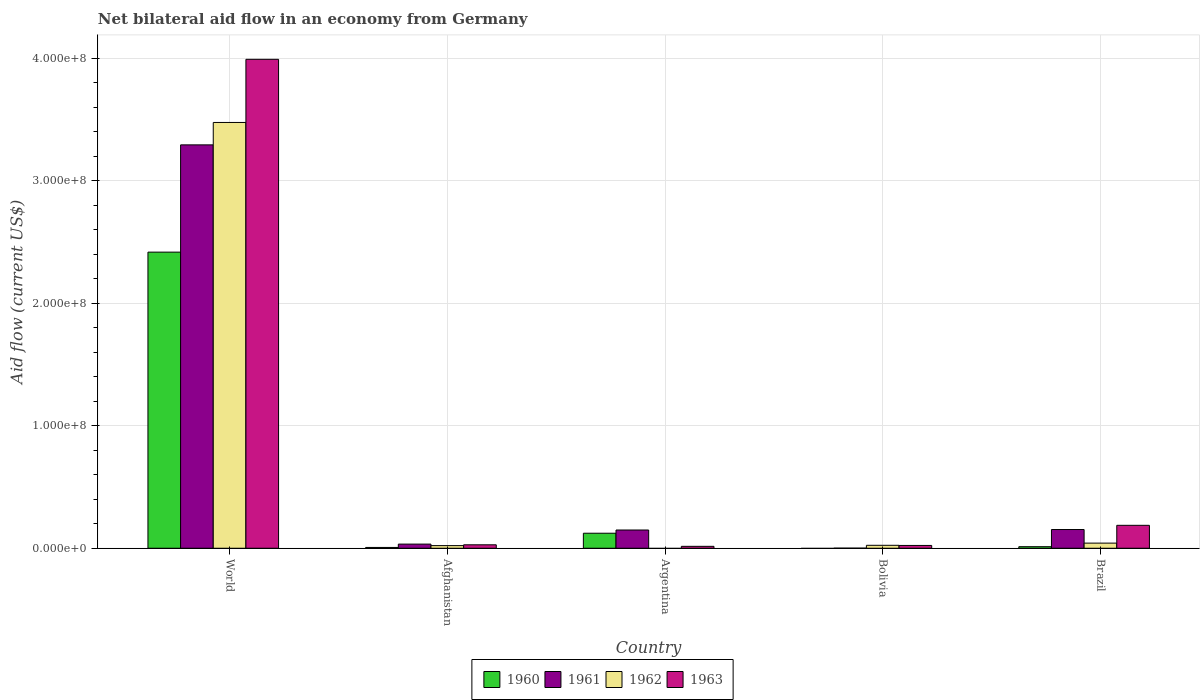How many groups of bars are there?
Your response must be concise. 5. Are the number of bars on each tick of the X-axis equal?
Give a very brief answer. No. How many bars are there on the 5th tick from the left?
Ensure brevity in your answer.  4. What is the net bilateral aid flow in 1963 in Bolivia?
Offer a very short reply. 2.28e+06. Across all countries, what is the maximum net bilateral aid flow in 1961?
Offer a terse response. 3.29e+08. What is the total net bilateral aid flow in 1963 in the graph?
Your answer should be compact. 4.24e+08. What is the difference between the net bilateral aid flow in 1963 in Argentina and that in Bolivia?
Your answer should be very brief. -7.20e+05. What is the difference between the net bilateral aid flow in 1960 in Brazil and the net bilateral aid flow in 1962 in Argentina?
Provide a succinct answer. 1.26e+06. What is the average net bilateral aid flow in 1962 per country?
Make the answer very short. 7.12e+07. What is the difference between the net bilateral aid flow of/in 1962 and net bilateral aid flow of/in 1960 in World?
Offer a very short reply. 1.06e+08. In how many countries, is the net bilateral aid flow in 1963 greater than 120000000 US$?
Your response must be concise. 1. What is the ratio of the net bilateral aid flow in 1962 in Afghanistan to that in World?
Offer a very short reply. 0.01. What is the difference between the highest and the second highest net bilateral aid flow in 1961?
Keep it short and to the point. 3.14e+08. What is the difference between the highest and the lowest net bilateral aid flow in 1963?
Your answer should be compact. 3.97e+08. In how many countries, is the net bilateral aid flow in 1960 greater than the average net bilateral aid flow in 1960 taken over all countries?
Make the answer very short. 1. Is it the case that in every country, the sum of the net bilateral aid flow in 1960 and net bilateral aid flow in 1963 is greater than the sum of net bilateral aid flow in 1962 and net bilateral aid flow in 1961?
Ensure brevity in your answer.  No. What is the difference between two consecutive major ticks on the Y-axis?
Offer a very short reply. 1.00e+08. Are the values on the major ticks of Y-axis written in scientific E-notation?
Provide a succinct answer. Yes. How are the legend labels stacked?
Provide a short and direct response. Horizontal. What is the title of the graph?
Provide a short and direct response. Net bilateral aid flow in an economy from Germany. What is the label or title of the X-axis?
Make the answer very short. Country. What is the Aid flow (current US$) of 1960 in World?
Keep it short and to the point. 2.42e+08. What is the Aid flow (current US$) of 1961 in World?
Your response must be concise. 3.29e+08. What is the Aid flow (current US$) in 1962 in World?
Your answer should be compact. 3.47e+08. What is the Aid flow (current US$) of 1963 in World?
Ensure brevity in your answer.  3.99e+08. What is the Aid flow (current US$) in 1960 in Afghanistan?
Provide a short and direct response. 6.50e+05. What is the Aid flow (current US$) of 1961 in Afghanistan?
Your answer should be compact. 3.38e+06. What is the Aid flow (current US$) of 1962 in Afghanistan?
Ensure brevity in your answer.  2.15e+06. What is the Aid flow (current US$) in 1963 in Afghanistan?
Your answer should be very brief. 2.81e+06. What is the Aid flow (current US$) in 1960 in Argentina?
Offer a terse response. 1.23e+07. What is the Aid flow (current US$) in 1961 in Argentina?
Provide a short and direct response. 1.49e+07. What is the Aid flow (current US$) of 1963 in Argentina?
Offer a terse response. 1.56e+06. What is the Aid flow (current US$) of 1961 in Bolivia?
Offer a terse response. 7.00e+04. What is the Aid flow (current US$) of 1962 in Bolivia?
Give a very brief answer. 2.40e+06. What is the Aid flow (current US$) of 1963 in Bolivia?
Make the answer very short. 2.28e+06. What is the Aid flow (current US$) in 1960 in Brazil?
Provide a short and direct response. 1.26e+06. What is the Aid flow (current US$) in 1961 in Brazil?
Offer a very short reply. 1.53e+07. What is the Aid flow (current US$) in 1962 in Brazil?
Provide a succinct answer. 4.19e+06. What is the Aid flow (current US$) of 1963 in Brazil?
Your answer should be very brief. 1.87e+07. Across all countries, what is the maximum Aid flow (current US$) in 1960?
Provide a succinct answer. 2.42e+08. Across all countries, what is the maximum Aid flow (current US$) in 1961?
Offer a very short reply. 3.29e+08. Across all countries, what is the maximum Aid flow (current US$) of 1962?
Offer a very short reply. 3.47e+08. Across all countries, what is the maximum Aid flow (current US$) in 1963?
Make the answer very short. 3.99e+08. Across all countries, what is the minimum Aid flow (current US$) of 1963?
Provide a succinct answer. 1.56e+06. What is the total Aid flow (current US$) in 1960 in the graph?
Your response must be concise. 2.56e+08. What is the total Aid flow (current US$) of 1961 in the graph?
Your answer should be very brief. 3.63e+08. What is the total Aid flow (current US$) of 1962 in the graph?
Provide a succinct answer. 3.56e+08. What is the total Aid flow (current US$) in 1963 in the graph?
Provide a succinct answer. 4.24e+08. What is the difference between the Aid flow (current US$) in 1960 in World and that in Afghanistan?
Provide a succinct answer. 2.41e+08. What is the difference between the Aid flow (current US$) of 1961 in World and that in Afghanistan?
Make the answer very short. 3.26e+08. What is the difference between the Aid flow (current US$) of 1962 in World and that in Afghanistan?
Your response must be concise. 3.45e+08. What is the difference between the Aid flow (current US$) in 1963 in World and that in Afghanistan?
Your answer should be compact. 3.96e+08. What is the difference between the Aid flow (current US$) of 1960 in World and that in Argentina?
Give a very brief answer. 2.29e+08. What is the difference between the Aid flow (current US$) of 1961 in World and that in Argentina?
Your answer should be very brief. 3.14e+08. What is the difference between the Aid flow (current US$) in 1963 in World and that in Argentina?
Keep it short and to the point. 3.97e+08. What is the difference between the Aid flow (current US$) in 1961 in World and that in Bolivia?
Offer a terse response. 3.29e+08. What is the difference between the Aid flow (current US$) of 1962 in World and that in Bolivia?
Your answer should be very brief. 3.45e+08. What is the difference between the Aid flow (current US$) in 1963 in World and that in Bolivia?
Your answer should be very brief. 3.97e+08. What is the difference between the Aid flow (current US$) of 1960 in World and that in Brazil?
Give a very brief answer. 2.40e+08. What is the difference between the Aid flow (current US$) of 1961 in World and that in Brazil?
Your answer should be very brief. 3.14e+08. What is the difference between the Aid flow (current US$) of 1962 in World and that in Brazil?
Provide a short and direct response. 3.43e+08. What is the difference between the Aid flow (current US$) in 1963 in World and that in Brazil?
Keep it short and to the point. 3.80e+08. What is the difference between the Aid flow (current US$) of 1960 in Afghanistan and that in Argentina?
Keep it short and to the point. -1.16e+07. What is the difference between the Aid flow (current US$) in 1961 in Afghanistan and that in Argentina?
Give a very brief answer. -1.15e+07. What is the difference between the Aid flow (current US$) in 1963 in Afghanistan and that in Argentina?
Ensure brevity in your answer.  1.25e+06. What is the difference between the Aid flow (current US$) of 1961 in Afghanistan and that in Bolivia?
Give a very brief answer. 3.31e+06. What is the difference between the Aid flow (current US$) of 1962 in Afghanistan and that in Bolivia?
Provide a short and direct response. -2.50e+05. What is the difference between the Aid flow (current US$) in 1963 in Afghanistan and that in Bolivia?
Make the answer very short. 5.30e+05. What is the difference between the Aid flow (current US$) of 1960 in Afghanistan and that in Brazil?
Offer a very short reply. -6.10e+05. What is the difference between the Aid flow (current US$) in 1961 in Afghanistan and that in Brazil?
Make the answer very short. -1.19e+07. What is the difference between the Aid flow (current US$) in 1962 in Afghanistan and that in Brazil?
Your response must be concise. -2.04e+06. What is the difference between the Aid flow (current US$) of 1963 in Afghanistan and that in Brazil?
Give a very brief answer. -1.59e+07. What is the difference between the Aid flow (current US$) of 1961 in Argentina and that in Bolivia?
Your answer should be very brief. 1.48e+07. What is the difference between the Aid flow (current US$) in 1963 in Argentina and that in Bolivia?
Your answer should be very brief. -7.20e+05. What is the difference between the Aid flow (current US$) of 1960 in Argentina and that in Brazil?
Give a very brief answer. 1.10e+07. What is the difference between the Aid flow (current US$) of 1961 in Argentina and that in Brazil?
Give a very brief answer. -3.90e+05. What is the difference between the Aid flow (current US$) of 1963 in Argentina and that in Brazil?
Ensure brevity in your answer.  -1.71e+07. What is the difference between the Aid flow (current US$) of 1961 in Bolivia and that in Brazil?
Keep it short and to the point. -1.52e+07. What is the difference between the Aid flow (current US$) of 1962 in Bolivia and that in Brazil?
Keep it short and to the point. -1.79e+06. What is the difference between the Aid flow (current US$) in 1963 in Bolivia and that in Brazil?
Your response must be concise. -1.64e+07. What is the difference between the Aid flow (current US$) in 1960 in World and the Aid flow (current US$) in 1961 in Afghanistan?
Make the answer very short. 2.38e+08. What is the difference between the Aid flow (current US$) of 1960 in World and the Aid flow (current US$) of 1962 in Afghanistan?
Make the answer very short. 2.39e+08. What is the difference between the Aid flow (current US$) of 1960 in World and the Aid flow (current US$) of 1963 in Afghanistan?
Your answer should be compact. 2.39e+08. What is the difference between the Aid flow (current US$) in 1961 in World and the Aid flow (current US$) in 1962 in Afghanistan?
Provide a succinct answer. 3.27e+08. What is the difference between the Aid flow (current US$) in 1961 in World and the Aid flow (current US$) in 1963 in Afghanistan?
Keep it short and to the point. 3.26e+08. What is the difference between the Aid flow (current US$) of 1962 in World and the Aid flow (current US$) of 1963 in Afghanistan?
Provide a succinct answer. 3.45e+08. What is the difference between the Aid flow (current US$) of 1960 in World and the Aid flow (current US$) of 1961 in Argentina?
Your response must be concise. 2.27e+08. What is the difference between the Aid flow (current US$) of 1960 in World and the Aid flow (current US$) of 1963 in Argentina?
Ensure brevity in your answer.  2.40e+08. What is the difference between the Aid flow (current US$) in 1961 in World and the Aid flow (current US$) in 1963 in Argentina?
Provide a succinct answer. 3.28e+08. What is the difference between the Aid flow (current US$) of 1962 in World and the Aid flow (current US$) of 1963 in Argentina?
Keep it short and to the point. 3.46e+08. What is the difference between the Aid flow (current US$) of 1960 in World and the Aid flow (current US$) of 1961 in Bolivia?
Your answer should be very brief. 2.42e+08. What is the difference between the Aid flow (current US$) of 1960 in World and the Aid flow (current US$) of 1962 in Bolivia?
Provide a succinct answer. 2.39e+08. What is the difference between the Aid flow (current US$) of 1960 in World and the Aid flow (current US$) of 1963 in Bolivia?
Your answer should be compact. 2.39e+08. What is the difference between the Aid flow (current US$) in 1961 in World and the Aid flow (current US$) in 1962 in Bolivia?
Make the answer very short. 3.27e+08. What is the difference between the Aid flow (current US$) of 1961 in World and the Aid flow (current US$) of 1963 in Bolivia?
Ensure brevity in your answer.  3.27e+08. What is the difference between the Aid flow (current US$) in 1962 in World and the Aid flow (current US$) in 1963 in Bolivia?
Give a very brief answer. 3.45e+08. What is the difference between the Aid flow (current US$) of 1960 in World and the Aid flow (current US$) of 1961 in Brazil?
Offer a terse response. 2.26e+08. What is the difference between the Aid flow (current US$) of 1960 in World and the Aid flow (current US$) of 1962 in Brazil?
Keep it short and to the point. 2.37e+08. What is the difference between the Aid flow (current US$) in 1960 in World and the Aid flow (current US$) in 1963 in Brazil?
Offer a terse response. 2.23e+08. What is the difference between the Aid flow (current US$) in 1961 in World and the Aid flow (current US$) in 1962 in Brazil?
Make the answer very short. 3.25e+08. What is the difference between the Aid flow (current US$) of 1961 in World and the Aid flow (current US$) of 1963 in Brazil?
Keep it short and to the point. 3.10e+08. What is the difference between the Aid flow (current US$) in 1962 in World and the Aid flow (current US$) in 1963 in Brazil?
Provide a succinct answer. 3.29e+08. What is the difference between the Aid flow (current US$) in 1960 in Afghanistan and the Aid flow (current US$) in 1961 in Argentina?
Your answer should be compact. -1.42e+07. What is the difference between the Aid flow (current US$) in 1960 in Afghanistan and the Aid flow (current US$) in 1963 in Argentina?
Keep it short and to the point. -9.10e+05. What is the difference between the Aid flow (current US$) in 1961 in Afghanistan and the Aid flow (current US$) in 1963 in Argentina?
Your answer should be very brief. 1.82e+06. What is the difference between the Aid flow (current US$) of 1962 in Afghanistan and the Aid flow (current US$) of 1963 in Argentina?
Make the answer very short. 5.90e+05. What is the difference between the Aid flow (current US$) of 1960 in Afghanistan and the Aid flow (current US$) of 1961 in Bolivia?
Your answer should be very brief. 5.80e+05. What is the difference between the Aid flow (current US$) in 1960 in Afghanistan and the Aid flow (current US$) in 1962 in Bolivia?
Provide a short and direct response. -1.75e+06. What is the difference between the Aid flow (current US$) in 1960 in Afghanistan and the Aid flow (current US$) in 1963 in Bolivia?
Provide a succinct answer. -1.63e+06. What is the difference between the Aid flow (current US$) of 1961 in Afghanistan and the Aid flow (current US$) of 1962 in Bolivia?
Offer a very short reply. 9.80e+05. What is the difference between the Aid flow (current US$) of 1961 in Afghanistan and the Aid flow (current US$) of 1963 in Bolivia?
Provide a short and direct response. 1.10e+06. What is the difference between the Aid flow (current US$) of 1960 in Afghanistan and the Aid flow (current US$) of 1961 in Brazil?
Offer a terse response. -1.46e+07. What is the difference between the Aid flow (current US$) in 1960 in Afghanistan and the Aid flow (current US$) in 1962 in Brazil?
Provide a short and direct response. -3.54e+06. What is the difference between the Aid flow (current US$) in 1960 in Afghanistan and the Aid flow (current US$) in 1963 in Brazil?
Your response must be concise. -1.80e+07. What is the difference between the Aid flow (current US$) of 1961 in Afghanistan and the Aid flow (current US$) of 1962 in Brazil?
Your response must be concise. -8.10e+05. What is the difference between the Aid flow (current US$) in 1961 in Afghanistan and the Aid flow (current US$) in 1963 in Brazil?
Your response must be concise. -1.53e+07. What is the difference between the Aid flow (current US$) in 1962 in Afghanistan and the Aid flow (current US$) in 1963 in Brazil?
Give a very brief answer. -1.66e+07. What is the difference between the Aid flow (current US$) of 1960 in Argentina and the Aid flow (current US$) of 1961 in Bolivia?
Give a very brief answer. 1.22e+07. What is the difference between the Aid flow (current US$) in 1960 in Argentina and the Aid flow (current US$) in 1962 in Bolivia?
Provide a succinct answer. 9.86e+06. What is the difference between the Aid flow (current US$) of 1960 in Argentina and the Aid flow (current US$) of 1963 in Bolivia?
Provide a succinct answer. 9.98e+06. What is the difference between the Aid flow (current US$) in 1961 in Argentina and the Aid flow (current US$) in 1962 in Bolivia?
Keep it short and to the point. 1.25e+07. What is the difference between the Aid flow (current US$) of 1961 in Argentina and the Aid flow (current US$) of 1963 in Bolivia?
Your response must be concise. 1.26e+07. What is the difference between the Aid flow (current US$) of 1960 in Argentina and the Aid flow (current US$) of 1961 in Brazil?
Give a very brief answer. -3.01e+06. What is the difference between the Aid flow (current US$) in 1960 in Argentina and the Aid flow (current US$) in 1962 in Brazil?
Provide a succinct answer. 8.07e+06. What is the difference between the Aid flow (current US$) of 1960 in Argentina and the Aid flow (current US$) of 1963 in Brazil?
Provide a succinct answer. -6.44e+06. What is the difference between the Aid flow (current US$) in 1961 in Argentina and the Aid flow (current US$) in 1962 in Brazil?
Your answer should be very brief. 1.07e+07. What is the difference between the Aid flow (current US$) in 1961 in Argentina and the Aid flow (current US$) in 1963 in Brazil?
Offer a very short reply. -3.82e+06. What is the difference between the Aid flow (current US$) of 1961 in Bolivia and the Aid flow (current US$) of 1962 in Brazil?
Ensure brevity in your answer.  -4.12e+06. What is the difference between the Aid flow (current US$) of 1961 in Bolivia and the Aid flow (current US$) of 1963 in Brazil?
Provide a succinct answer. -1.86e+07. What is the difference between the Aid flow (current US$) of 1962 in Bolivia and the Aid flow (current US$) of 1963 in Brazil?
Offer a terse response. -1.63e+07. What is the average Aid flow (current US$) of 1960 per country?
Give a very brief answer. 5.12e+07. What is the average Aid flow (current US$) of 1961 per country?
Give a very brief answer. 7.25e+07. What is the average Aid flow (current US$) in 1962 per country?
Ensure brevity in your answer.  7.12e+07. What is the average Aid flow (current US$) in 1963 per country?
Provide a succinct answer. 8.49e+07. What is the difference between the Aid flow (current US$) in 1960 and Aid flow (current US$) in 1961 in World?
Your answer should be very brief. -8.75e+07. What is the difference between the Aid flow (current US$) of 1960 and Aid flow (current US$) of 1962 in World?
Keep it short and to the point. -1.06e+08. What is the difference between the Aid flow (current US$) in 1960 and Aid flow (current US$) in 1963 in World?
Make the answer very short. -1.57e+08. What is the difference between the Aid flow (current US$) in 1961 and Aid flow (current US$) in 1962 in World?
Your answer should be compact. -1.83e+07. What is the difference between the Aid flow (current US$) in 1961 and Aid flow (current US$) in 1963 in World?
Keep it short and to the point. -6.98e+07. What is the difference between the Aid flow (current US$) of 1962 and Aid flow (current US$) of 1963 in World?
Give a very brief answer. -5.15e+07. What is the difference between the Aid flow (current US$) of 1960 and Aid flow (current US$) of 1961 in Afghanistan?
Ensure brevity in your answer.  -2.73e+06. What is the difference between the Aid flow (current US$) of 1960 and Aid flow (current US$) of 1962 in Afghanistan?
Your answer should be very brief. -1.50e+06. What is the difference between the Aid flow (current US$) in 1960 and Aid flow (current US$) in 1963 in Afghanistan?
Ensure brevity in your answer.  -2.16e+06. What is the difference between the Aid flow (current US$) of 1961 and Aid flow (current US$) of 1962 in Afghanistan?
Keep it short and to the point. 1.23e+06. What is the difference between the Aid flow (current US$) in 1961 and Aid flow (current US$) in 1963 in Afghanistan?
Give a very brief answer. 5.70e+05. What is the difference between the Aid flow (current US$) in 1962 and Aid flow (current US$) in 1963 in Afghanistan?
Give a very brief answer. -6.60e+05. What is the difference between the Aid flow (current US$) in 1960 and Aid flow (current US$) in 1961 in Argentina?
Provide a succinct answer. -2.62e+06. What is the difference between the Aid flow (current US$) of 1960 and Aid flow (current US$) of 1963 in Argentina?
Provide a succinct answer. 1.07e+07. What is the difference between the Aid flow (current US$) of 1961 and Aid flow (current US$) of 1963 in Argentina?
Your response must be concise. 1.33e+07. What is the difference between the Aid flow (current US$) in 1961 and Aid flow (current US$) in 1962 in Bolivia?
Provide a succinct answer. -2.33e+06. What is the difference between the Aid flow (current US$) of 1961 and Aid flow (current US$) of 1963 in Bolivia?
Provide a succinct answer. -2.21e+06. What is the difference between the Aid flow (current US$) of 1962 and Aid flow (current US$) of 1963 in Bolivia?
Provide a short and direct response. 1.20e+05. What is the difference between the Aid flow (current US$) of 1960 and Aid flow (current US$) of 1961 in Brazil?
Your answer should be compact. -1.40e+07. What is the difference between the Aid flow (current US$) in 1960 and Aid flow (current US$) in 1962 in Brazil?
Your response must be concise. -2.93e+06. What is the difference between the Aid flow (current US$) of 1960 and Aid flow (current US$) of 1963 in Brazil?
Provide a succinct answer. -1.74e+07. What is the difference between the Aid flow (current US$) of 1961 and Aid flow (current US$) of 1962 in Brazil?
Give a very brief answer. 1.11e+07. What is the difference between the Aid flow (current US$) of 1961 and Aid flow (current US$) of 1963 in Brazil?
Your answer should be compact. -3.43e+06. What is the difference between the Aid flow (current US$) in 1962 and Aid flow (current US$) in 1963 in Brazil?
Offer a terse response. -1.45e+07. What is the ratio of the Aid flow (current US$) in 1960 in World to that in Afghanistan?
Give a very brief answer. 371.71. What is the ratio of the Aid flow (current US$) in 1961 in World to that in Afghanistan?
Keep it short and to the point. 97.38. What is the ratio of the Aid flow (current US$) in 1962 in World to that in Afghanistan?
Give a very brief answer. 161.59. What is the ratio of the Aid flow (current US$) in 1963 in World to that in Afghanistan?
Your answer should be compact. 141.97. What is the ratio of the Aid flow (current US$) in 1960 in World to that in Argentina?
Offer a very short reply. 19.71. What is the ratio of the Aid flow (current US$) of 1961 in World to that in Argentina?
Your answer should be very brief. 22.12. What is the ratio of the Aid flow (current US$) in 1963 in World to that in Argentina?
Make the answer very short. 255.72. What is the ratio of the Aid flow (current US$) in 1961 in World to that in Bolivia?
Make the answer very short. 4701.86. What is the ratio of the Aid flow (current US$) in 1962 in World to that in Bolivia?
Your answer should be compact. 144.75. What is the ratio of the Aid flow (current US$) in 1963 in World to that in Bolivia?
Provide a short and direct response. 174.97. What is the ratio of the Aid flow (current US$) of 1960 in World to that in Brazil?
Your answer should be compact. 191.75. What is the ratio of the Aid flow (current US$) of 1961 in World to that in Brazil?
Your answer should be compact. 21.55. What is the ratio of the Aid flow (current US$) of 1962 in World to that in Brazil?
Offer a very short reply. 82.91. What is the ratio of the Aid flow (current US$) of 1963 in World to that in Brazil?
Your answer should be compact. 21.33. What is the ratio of the Aid flow (current US$) of 1960 in Afghanistan to that in Argentina?
Your answer should be very brief. 0.05. What is the ratio of the Aid flow (current US$) of 1961 in Afghanistan to that in Argentina?
Offer a very short reply. 0.23. What is the ratio of the Aid flow (current US$) in 1963 in Afghanistan to that in Argentina?
Ensure brevity in your answer.  1.8. What is the ratio of the Aid flow (current US$) of 1961 in Afghanistan to that in Bolivia?
Your answer should be compact. 48.29. What is the ratio of the Aid flow (current US$) in 1962 in Afghanistan to that in Bolivia?
Your answer should be very brief. 0.9. What is the ratio of the Aid flow (current US$) of 1963 in Afghanistan to that in Bolivia?
Provide a succinct answer. 1.23. What is the ratio of the Aid flow (current US$) of 1960 in Afghanistan to that in Brazil?
Keep it short and to the point. 0.52. What is the ratio of the Aid flow (current US$) of 1961 in Afghanistan to that in Brazil?
Provide a succinct answer. 0.22. What is the ratio of the Aid flow (current US$) in 1962 in Afghanistan to that in Brazil?
Your answer should be very brief. 0.51. What is the ratio of the Aid flow (current US$) in 1963 in Afghanistan to that in Brazil?
Provide a short and direct response. 0.15. What is the ratio of the Aid flow (current US$) of 1961 in Argentina to that in Bolivia?
Offer a terse response. 212.57. What is the ratio of the Aid flow (current US$) of 1963 in Argentina to that in Bolivia?
Ensure brevity in your answer.  0.68. What is the ratio of the Aid flow (current US$) in 1960 in Argentina to that in Brazil?
Your response must be concise. 9.73. What is the ratio of the Aid flow (current US$) of 1961 in Argentina to that in Brazil?
Provide a short and direct response. 0.97. What is the ratio of the Aid flow (current US$) of 1963 in Argentina to that in Brazil?
Give a very brief answer. 0.08. What is the ratio of the Aid flow (current US$) of 1961 in Bolivia to that in Brazil?
Your answer should be very brief. 0. What is the ratio of the Aid flow (current US$) of 1962 in Bolivia to that in Brazil?
Ensure brevity in your answer.  0.57. What is the ratio of the Aid flow (current US$) of 1963 in Bolivia to that in Brazil?
Your response must be concise. 0.12. What is the difference between the highest and the second highest Aid flow (current US$) of 1960?
Your response must be concise. 2.29e+08. What is the difference between the highest and the second highest Aid flow (current US$) of 1961?
Provide a short and direct response. 3.14e+08. What is the difference between the highest and the second highest Aid flow (current US$) of 1962?
Keep it short and to the point. 3.43e+08. What is the difference between the highest and the second highest Aid flow (current US$) of 1963?
Keep it short and to the point. 3.80e+08. What is the difference between the highest and the lowest Aid flow (current US$) of 1960?
Offer a very short reply. 2.42e+08. What is the difference between the highest and the lowest Aid flow (current US$) in 1961?
Provide a succinct answer. 3.29e+08. What is the difference between the highest and the lowest Aid flow (current US$) in 1962?
Offer a terse response. 3.47e+08. What is the difference between the highest and the lowest Aid flow (current US$) of 1963?
Give a very brief answer. 3.97e+08. 